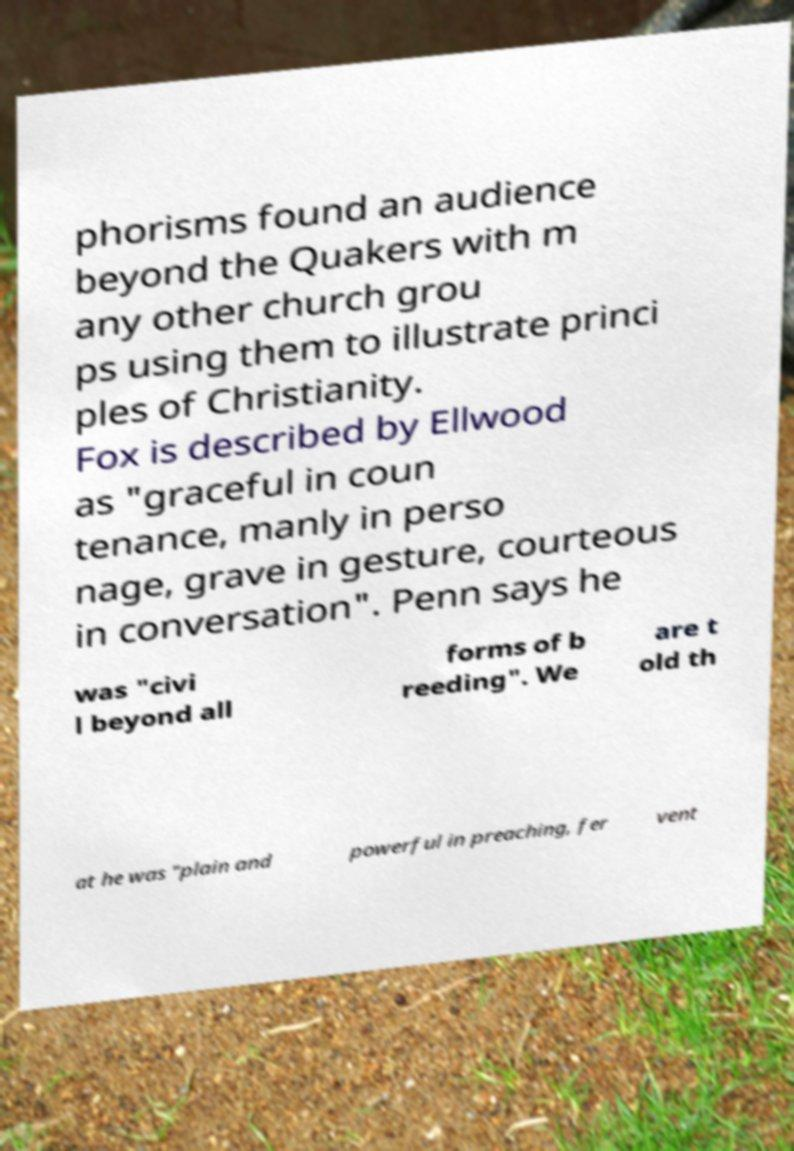There's text embedded in this image that I need extracted. Can you transcribe it verbatim? phorisms found an audience beyond the Quakers with m any other church grou ps using them to illustrate princi ples of Christianity. Fox is described by Ellwood as "graceful in coun tenance, manly in perso nage, grave in gesture, courteous in conversation". Penn says he was "civi l beyond all forms of b reeding". We are t old th at he was "plain and powerful in preaching, fer vent 